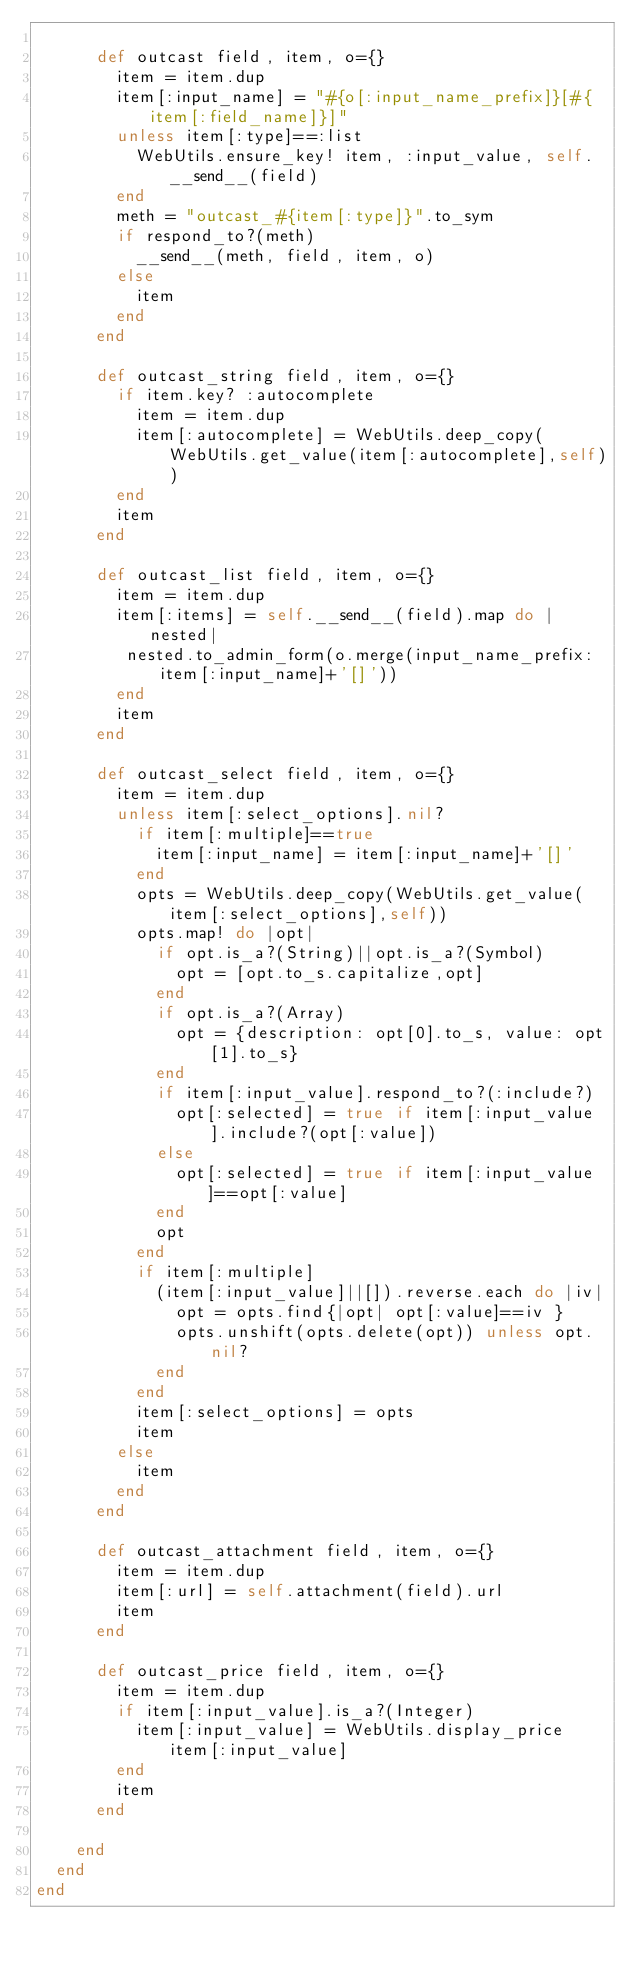Convert code to text. <code><loc_0><loc_0><loc_500><loc_500><_Ruby_>
      def outcast field, item, o={}
        item = item.dup
        item[:input_name] = "#{o[:input_name_prefix]}[#{item[:field_name]}]"
        unless item[:type]==:list
          WebUtils.ensure_key! item, :input_value, self.__send__(field)
        end
        meth = "outcast_#{item[:type]}".to_sym
        if respond_to?(meth)
          __send__(meth, field, item, o) 
        else
          item
        end
      end

      def outcast_string field, item, o={}
        if item.key? :autocomplete
          item = item.dup
          item[:autocomplete] = WebUtils.deep_copy(WebUtils.get_value(item[:autocomplete],self))
        end
        item
      end

      def outcast_list field, item, o={}
        item = item.dup
        item[:items] = self.__send__(field).map do |nested|
         nested.to_admin_form(o.merge(input_name_prefix: item[:input_name]+'[]'))
        end
        item
      end

      def outcast_select field, item, o={}
        item = item.dup
        unless item[:select_options].nil?
          if item[:multiple]==true
            item[:input_name] = item[:input_name]+'[]'
          end
          opts = WebUtils.deep_copy(WebUtils.get_value(item[:select_options],self))
          opts.map! do |opt|
            if opt.is_a?(String)||opt.is_a?(Symbol)
              opt = [opt.to_s.capitalize,opt]
            end
            if opt.is_a?(Array)
              opt = {description: opt[0].to_s, value: opt[1].to_s}
            end
            if item[:input_value].respond_to?(:include?)
              opt[:selected] = true if item[:input_value].include?(opt[:value])
            else
              opt[:selected] = true if item[:input_value]==opt[:value]
            end
            opt
          end
          if item[:multiple]
            (item[:input_value]||[]).reverse.each do |iv|
              opt = opts.find{|opt| opt[:value]==iv }
              opts.unshift(opts.delete(opt)) unless opt.nil?
            end
          end
          item[:select_options] = opts
          item
        else
          item
        end
      end

      def outcast_attachment field, item, o={}
        item = item.dup
        item[:url] = self.attachment(field).url
        item
      end

      def outcast_price field, item, o={}
        item = item.dup
        if item[:input_value].is_a?(Integer)
          item[:input_value] = WebUtils.display_price item[:input_value]
        end
        item
      end

    end
  end
end

</code> 